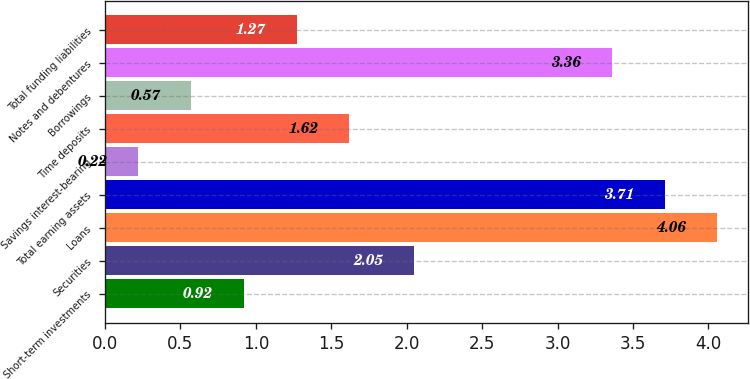<chart> <loc_0><loc_0><loc_500><loc_500><bar_chart><fcel>Short-term investments<fcel>Securities<fcel>Loans<fcel>Total earning assets<fcel>Savings interest-bearing<fcel>Time deposits<fcel>Borrowings<fcel>Notes and debentures<fcel>Total funding liabilities<nl><fcel>0.92<fcel>2.05<fcel>4.06<fcel>3.71<fcel>0.22<fcel>1.62<fcel>0.57<fcel>3.36<fcel>1.27<nl></chart> 